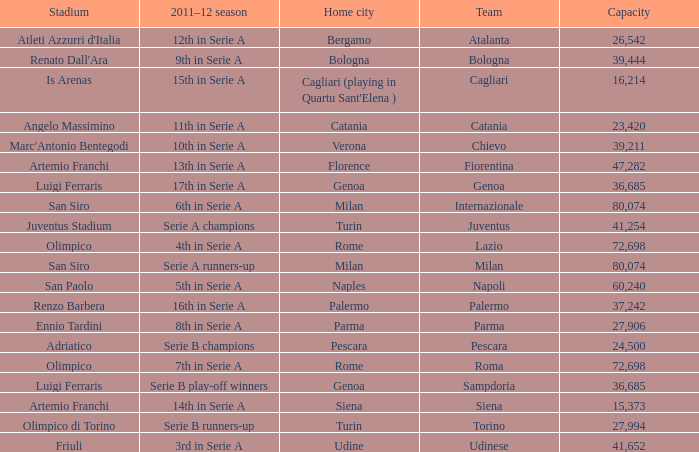Could you help me parse every detail presented in this table? {'header': ['Stadium', '2011–12 season', 'Home city', 'Team', 'Capacity'], 'rows': [["Atleti Azzurri d'Italia", '12th in Serie A', 'Bergamo', 'Atalanta', '26,542'], ["Renato Dall'Ara", '9th in Serie A', 'Bologna', 'Bologna', '39,444'], ['Is Arenas', '15th in Serie A', "Cagliari (playing in Quartu Sant'Elena )", 'Cagliari', '16,214'], ['Angelo Massimino', '11th in Serie A', 'Catania', 'Catania', '23,420'], ["Marc'Antonio Bentegodi", '10th in Serie A', 'Verona', 'Chievo', '39,211'], ['Artemio Franchi', '13th in Serie A', 'Florence', 'Fiorentina', '47,282'], ['Luigi Ferraris', '17th in Serie A', 'Genoa', 'Genoa', '36,685'], ['San Siro', '6th in Serie A', 'Milan', 'Internazionale', '80,074'], ['Juventus Stadium', 'Serie A champions', 'Turin', 'Juventus', '41,254'], ['Olimpico', '4th in Serie A', 'Rome', 'Lazio', '72,698'], ['San Siro', 'Serie A runners-up', 'Milan', 'Milan', '80,074'], ['San Paolo', '5th in Serie A', 'Naples', 'Napoli', '60,240'], ['Renzo Barbera', '16th in Serie A', 'Palermo', 'Palermo', '37,242'], ['Ennio Tardini', '8th in Serie A', 'Parma', 'Parma', '27,906'], ['Adriatico', 'Serie B champions', 'Pescara', 'Pescara', '24,500'], ['Olimpico', '7th in Serie A', 'Rome', 'Roma', '72,698'], ['Luigi Ferraris', 'Serie B play-off winners', 'Genoa', 'Sampdoria', '36,685'], ['Artemio Franchi', '14th in Serie A', 'Siena', 'Siena', '15,373'], ['Olimpico di Torino', 'Serie B runners-up', 'Turin', 'Torino', '27,994'], ['Friuli', '3rd in Serie A', 'Udine', 'Udinese', '41,652']]} What team had a capacity of over 26,542, a home city of milan, and finished the 2011-2012 season 6th in serie a? Internazionale. 